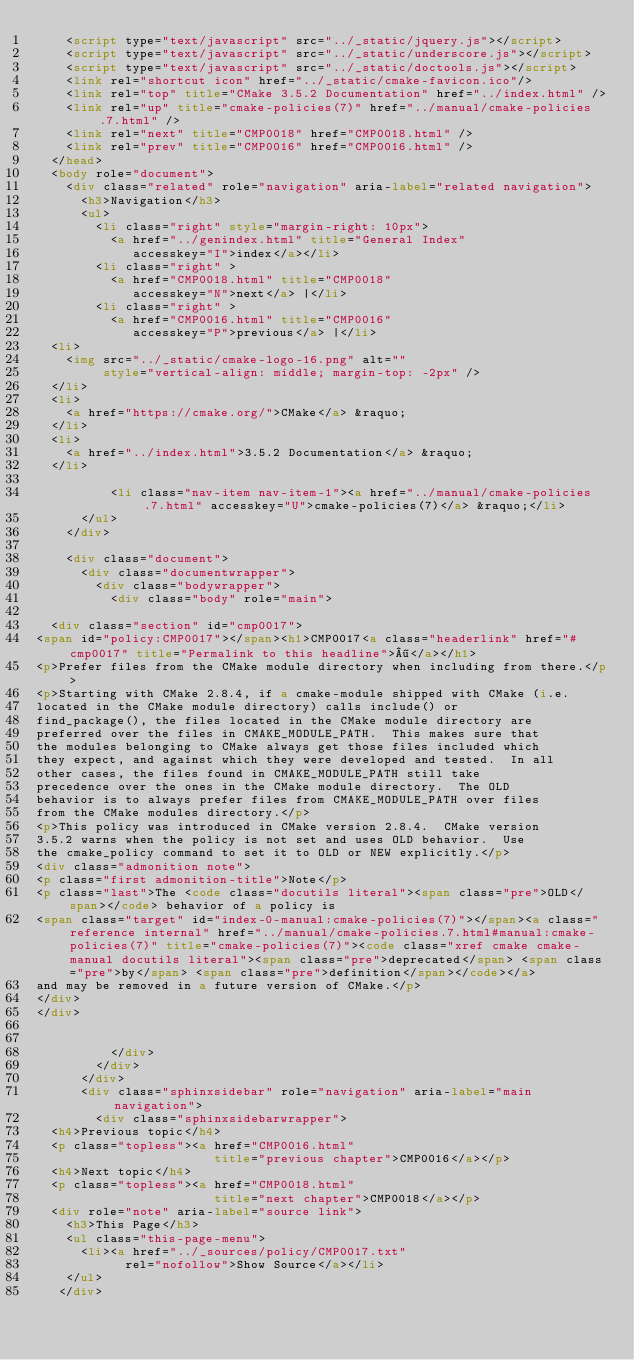<code> <loc_0><loc_0><loc_500><loc_500><_HTML_>    <script type="text/javascript" src="../_static/jquery.js"></script>
    <script type="text/javascript" src="../_static/underscore.js"></script>
    <script type="text/javascript" src="../_static/doctools.js"></script>
    <link rel="shortcut icon" href="../_static/cmake-favicon.ico"/>
    <link rel="top" title="CMake 3.5.2 Documentation" href="../index.html" />
    <link rel="up" title="cmake-policies(7)" href="../manual/cmake-policies.7.html" />
    <link rel="next" title="CMP0018" href="CMP0018.html" />
    <link rel="prev" title="CMP0016" href="CMP0016.html" /> 
  </head>
  <body role="document">
    <div class="related" role="navigation" aria-label="related navigation">
      <h3>Navigation</h3>
      <ul>
        <li class="right" style="margin-right: 10px">
          <a href="../genindex.html" title="General Index"
             accesskey="I">index</a></li>
        <li class="right" >
          <a href="CMP0018.html" title="CMP0018"
             accesskey="N">next</a> |</li>
        <li class="right" >
          <a href="CMP0016.html" title="CMP0016"
             accesskey="P">previous</a> |</li>
  <li>
    <img src="../_static/cmake-logo-16.png" alt=""
         style="vertical-align: middle; margin-top: -2px" />
  </li>
  <li>
    <a href="https://cmake.org/">CMake</a> &raquo;
  </li>
  <li>
    <a href="../index.html">3.5.2 Documentation</a> &raquo;
  </li>

          <li class="nav-item nav-item-1"><a href="../manual/cmake-policies.7.html" accesskey="U">cmake-policies(7)</a> &raquo;</li> 
      </ul>
    </div>  

    <div class="document">
      <div class="documentwrapper">
        <div class="bodywrapper">
          <div class="body" role="main">
            
  <div class="section" id="cmp0017">
<span id="policy:CMP0017"></span><h1>CMP0017<a class="headerlink" href="#cmp0017" title="Permalink to this headline">¶</a></h1>
<p>Prefer files from the CMake module directory when including from there.</p>
<p>Starting with CMake 2.8.4, if a cmake-module shipped with CMake (i.e.
located in the CMake module directory) calls include() or
find_package(), the files located in the CMake module directory are
preferred over the files in CMAKE_MODULE_PATH.  This makes sure that
the modules belonging to CMake always get those files included which
they expect, and against which they were developed and tested.  In all
other cases, the files found in CMAKE_MODULE_PATH still take
precedence over the ones in the CMake module directory.  The OLD
behavior is to always prefer files from CMAKE_MODULE_PATH over files
from the CMake modules directory.</p>
<p>This policy was introduced in CMake version 2.8.4.  CMake version
3.5.2 warns when the policy is not set and uses OLD behavior.  Use
the cmake_policy command to set it to OLD or NEW explicitly.</p>
<div class="admonition note">
<p class="first admonition-title">Note</p>
<p class="last">The <code class="docutils literal"><span class="pre">OLD</span></code> behavior of a policy is
<span class="target" id="index-0-manual:cmake-policies(7)"></span><a class="reference internal" href="../manual/cmake-policies.7.html#manual:cmake-policies(7)" title="cmake-policies(7)"><code class="xref cmake cmake-manual docutils literal"><span class="pre">deprecated</span> <span class="pre">by</span> <span class="pre">definition</span></code></a>
and may be removed in a future version of CMake.</p>
</div>
</div>


          </div>
        </div>
      </div>
      <div class="sphinxsidebar" role="navigation" aria-label="main navigation">
        <div class="sphinxsidebarwrapper">
  <h4>Previous topic</h4>
  <p class="topless"><a href="CMP0016.html"
                        title="previous chapter">CMP0016</a></p>
  <h4>Next topic</h4>
  <p class="topless"><a href="CMP0018.html"
                        title="next chapter">CMP0018</a></p>
  <div role="note" aria-label="source link">
    <h3>This Page</h3>
    <ul class="this-page-menu">
      <li><a href="../_sources/policy/CMP0017.txt"
            rel="nofollow">Show Source</a></li>
    </ul>
   </div></code> 